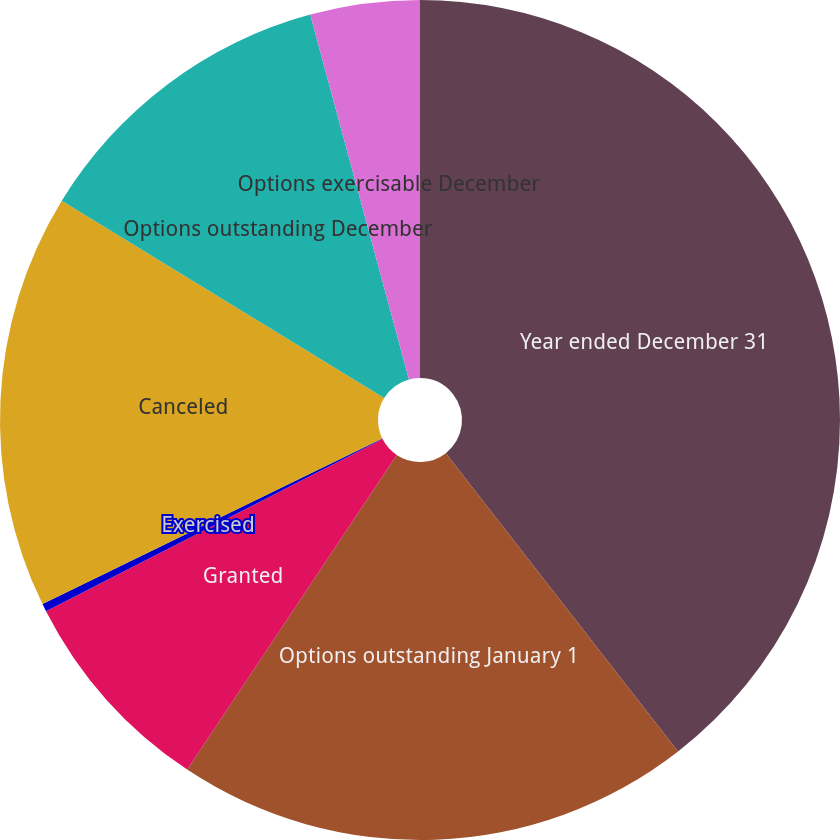Convert chart to OTSL. <chart><loc_0><loc_0><loc_500><loc_500><pie_chart><fcel>Year ended December 31<fcel>Options outstanding January 1<fcel>Granted<fcel>Exercised<fcel>Canceled<fcel>Options outstanding December<fcel>Options exercisable December<nl><fcel>39.47%<fcel>19.88%<fcel>8.13%<fcel>0.3%<fcel>15.96%<fcel>12.05%<fcel>4.21%<nl></chart> 